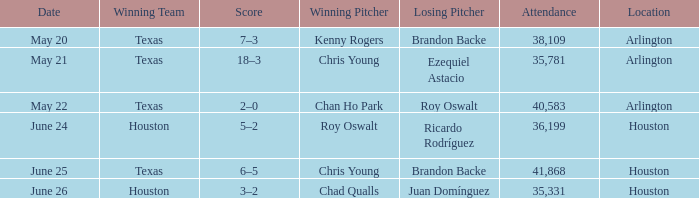Which place has a date of may 21? Arlington. 